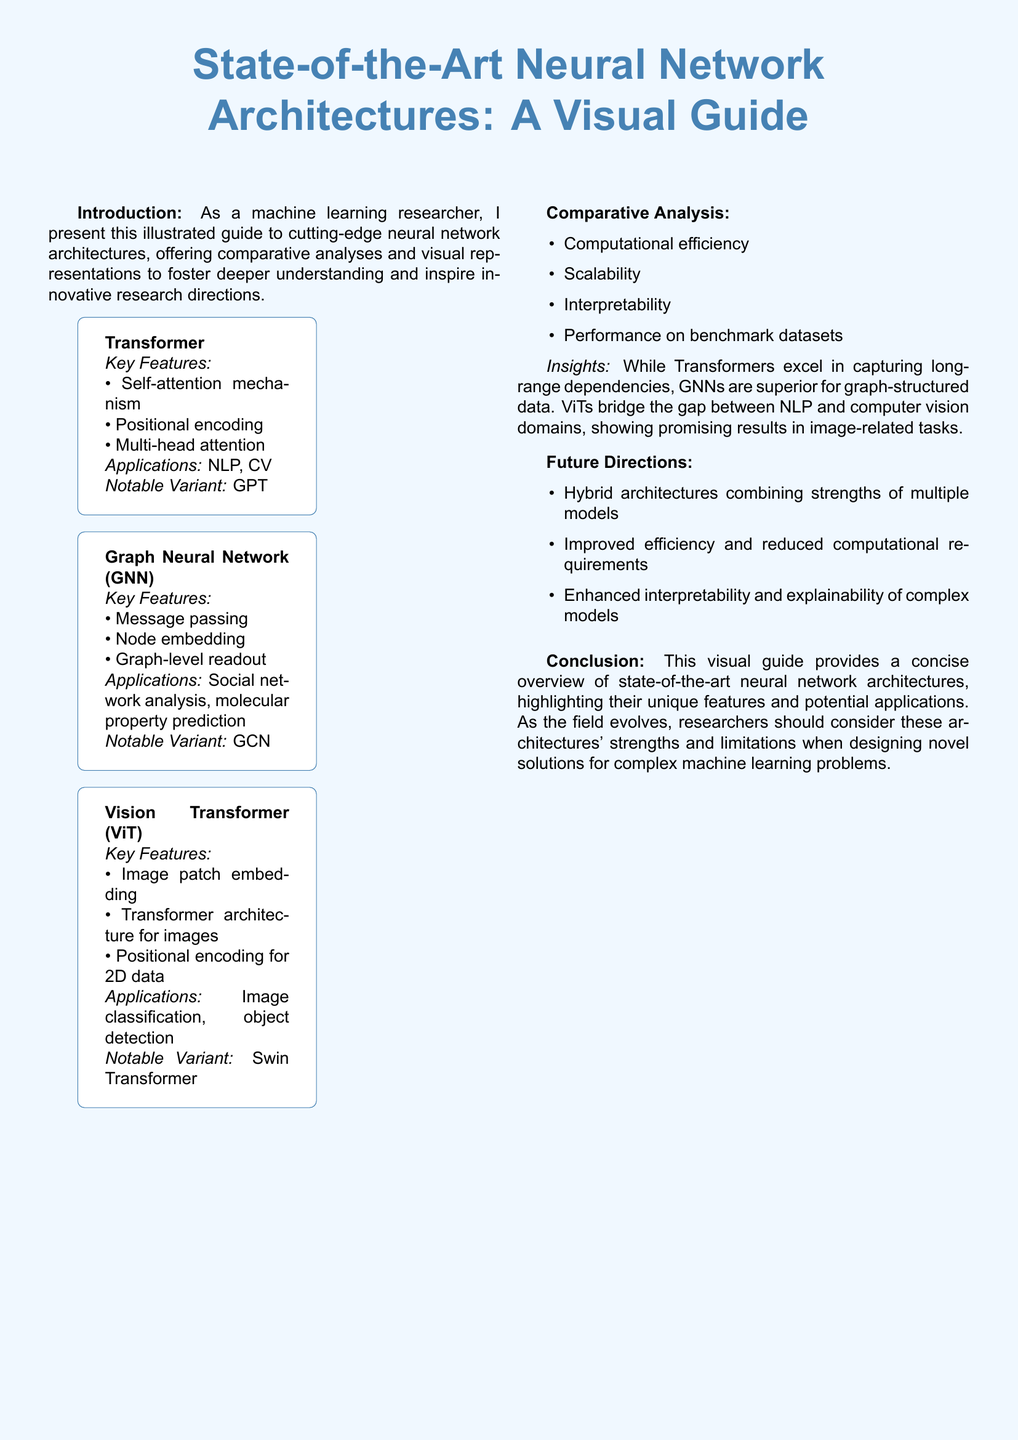What is the main focus of the guide? The guide presents state-of-the-art neural network architectures, offering comparative analyses and visual representations.
Answer: state-of-the-art neural network architectures What does GNN stand for? GNN is mentioned in the document and it stands for Graph Neural Network.
Answer: Graph Neural Network What is a notable variant of the Vision Transformer? The document specifies that a notable variant of the Vision Transformer is Swin Transformer.
Answer: Swin Transformer What are the two applications of Transformers mentioned? The applications listed for Transformers in the document are NLP and CV.
Answer: NLP, CV Which neural network architecture is noted for image classification? The document states that the Vision Transformer (ViT) is used for image classification.
Answer: Vision Transformer (ViT) What key feature distinguishes GNNs from other architectures? The key feature of GNNs that is highlighted is message passing.
Answer: message passing Which aspect does not belong to the comparative analysis mentioned? The document includes computational efficiency, scalability, interpretableness, and performance on benchmark datasets as aspects of the comparative analysis, but not model size.
Answer: model size What future direction involves combining multiple models? The future direction mentioned in the document focuses on hybrid architectures combining strengths of multiple models.
Answer: Hybrid architectures combining strengths of multiple models What does the conclusion suggest researchers consider? The conclusion suggests that researchers should consider these architectures' strengths and limitations.
Answer: strengths and limitations 